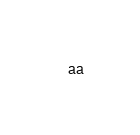Convert code to text. <code><loc_0><loc_0><loc_500><loc_500><_Python_>aa


</code> 